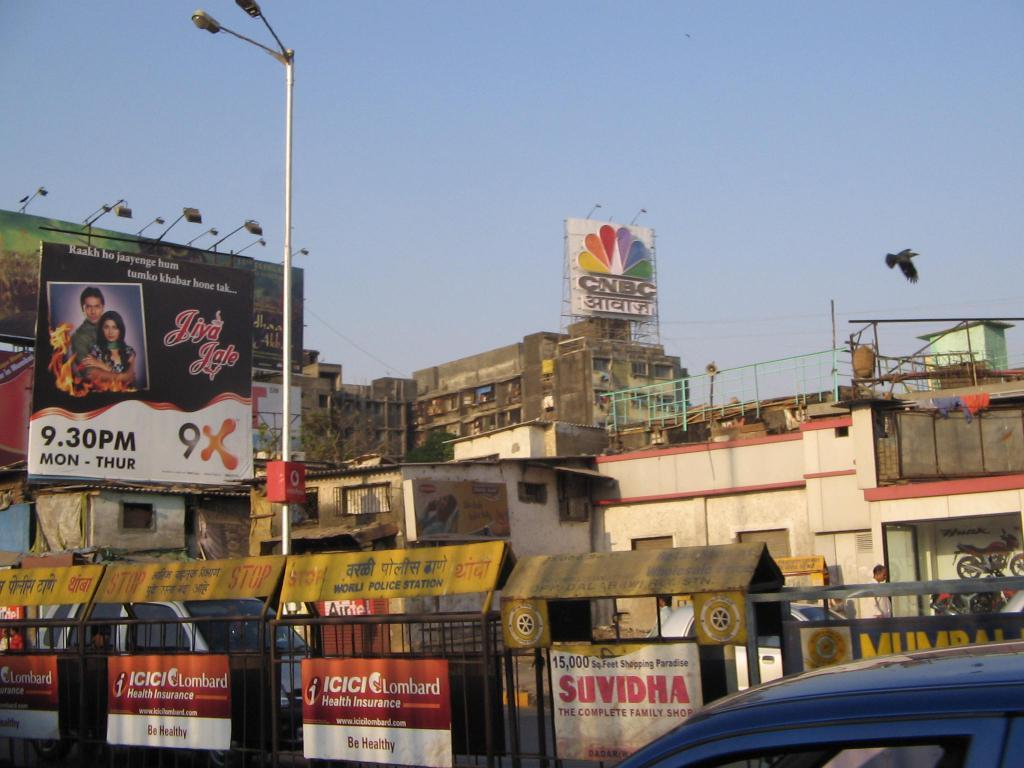<image>
Present a compact description of the photo's key features. A sign for CNBC is seen in the background of some buildings. 